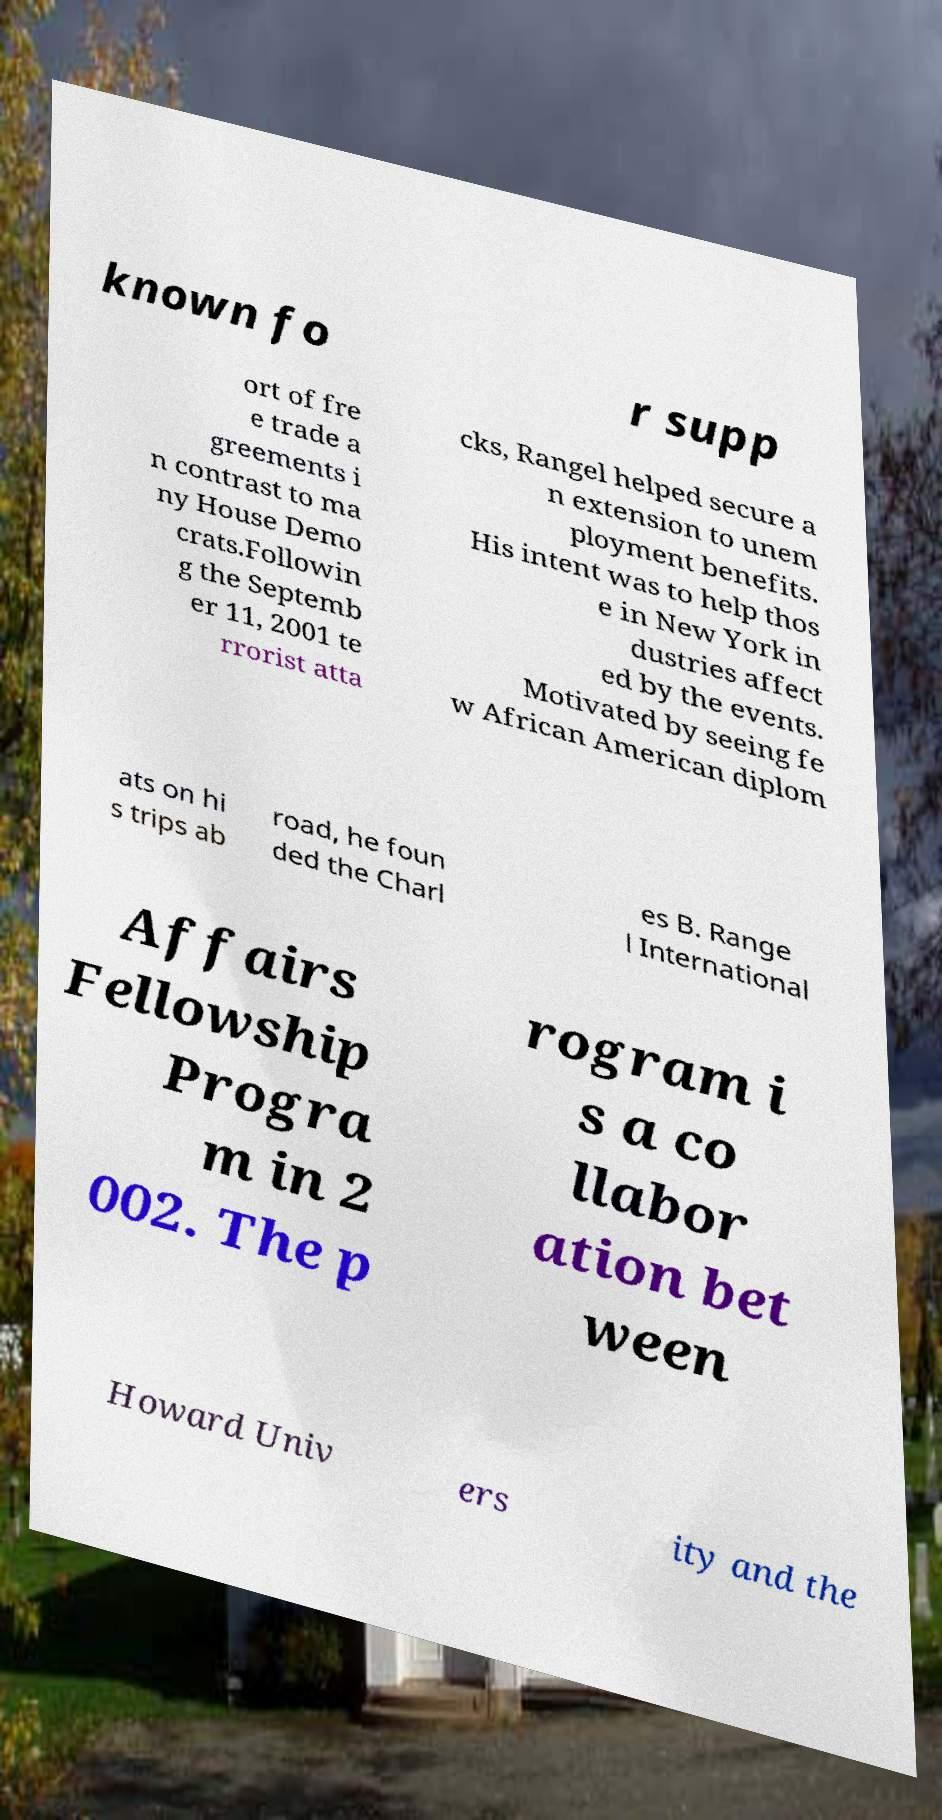Please identify and transcribe the text found in this image. known fo r supp ort of fre e trade a greements i n contrast to ma ny House Demo crats.Followin g the Septemb er 11, 2001 te rrorist atta cks, Rangel helped secure a n extension to unem ployment benefits. His intent was to help thos e in New York in dustries affect ed by the events. Motivated by seeing fe w African American diplom ats on hi s trips ab road, he foun ded the Charl es B. Range l International Affairs Fellowship Progra m in 2 002. The p rogram i s a co llabor ation bet ween Howard Univ ers ity and the 